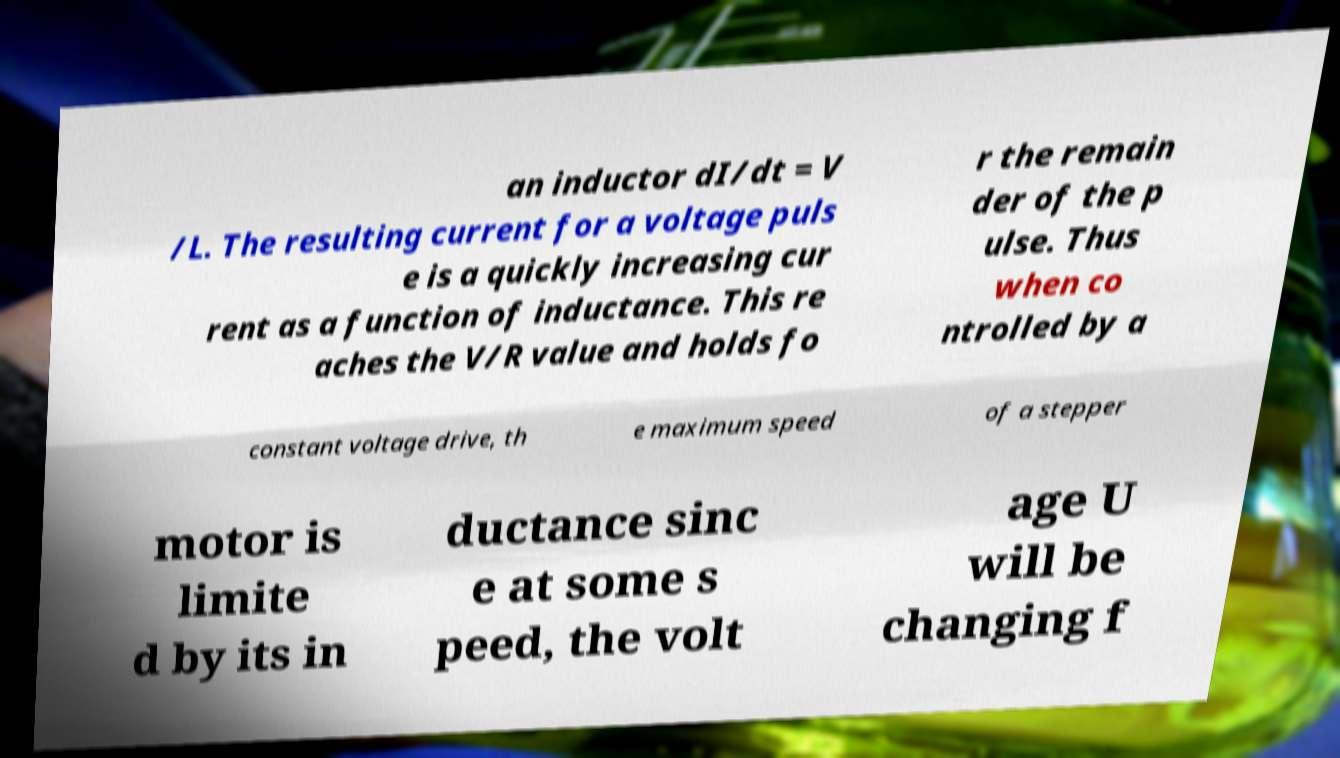I need the written content from this picture converted into text. Can you do that? an inductor dI/dt = V /L. The resulting current for a voltage puls e is a quickly increasing cur rent as a function of inductance. This re aches the V/R value and holds fo r the remain der of the p ulse. Thus when co ntrolled by a constant voltage drive, th e maximum speed of a stepper motor is limite d by its in ductance sinc e at some s peed, the volt age U will be changing f 